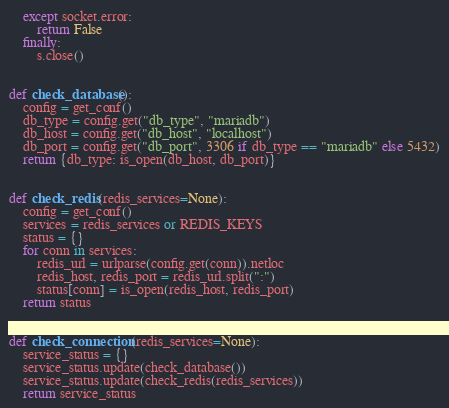Convert code to text. <code><loc_0><loc_0><loc_500><loc_500><_Python_>	except socket.error:
		return False
	finally:
		s.close()


def check_database():
	config = get_conf()
	db_type = config.get("db_type", "mariadb")
	db_host = config.get("db_host", "localhost")
	db_port = config.get("db_port", 3306 if db_type == "mariadb" else 5432)
	return {db_type: is_open(db_host, db_port)}


def check_redis(redis_services=None):
	config = get_conf()
	services = redis_services or REDIS_KEYS
	status = {}
	for conn in services:
		redis_url = urlparse(config.get(conn)).netloc
		redis_host, redis_port = redis_url.split(":")
		status[conn] = is_open(redis_host, redis_port)
	return status


def check_connection(redis_services=None):
	service_status = {}
	service_status.update(check_database())
	service_status.update(check_redis(redis_services))
	return service_status
</code> 